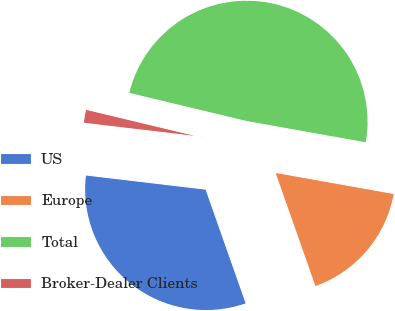Convert chart. <chart><loc_0><loc_0><loc_500><loc_500><pie_chart><fcel>US<fcel>Europe<fcel>Total<fcel>Broker-Dealer Clients<nl><fcel>32.26%<fcel>16.8%<fcel>49.07%<fcel>1.87%<nl></chart> 